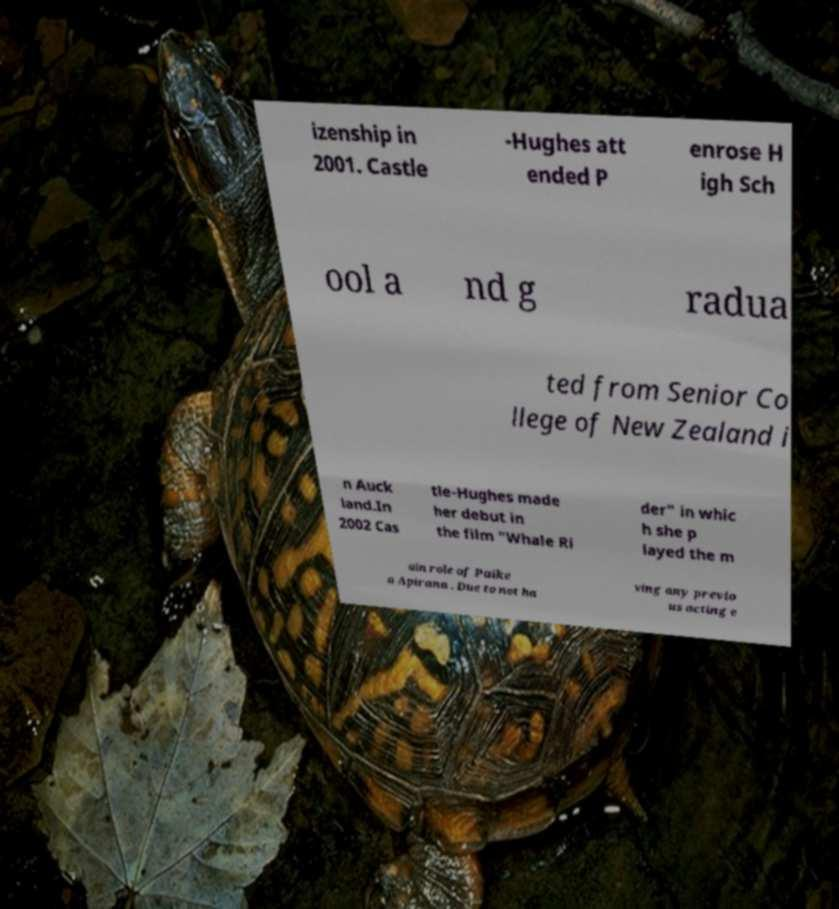Could you assist in decoding the text presented in this image and type it out clearly? izenship in 2001. Castle -Hughes att ended P enrose H igh Sch ool a nd g radua ted from Senior Co llege of New Zealand i n Auck land.In 2002 Cas tle-Hughes made her debut in the film "Whale Ri der" in whic h she p layed the m ain role of Paike a Apirana . Due to not ha ving any previo us acting e 